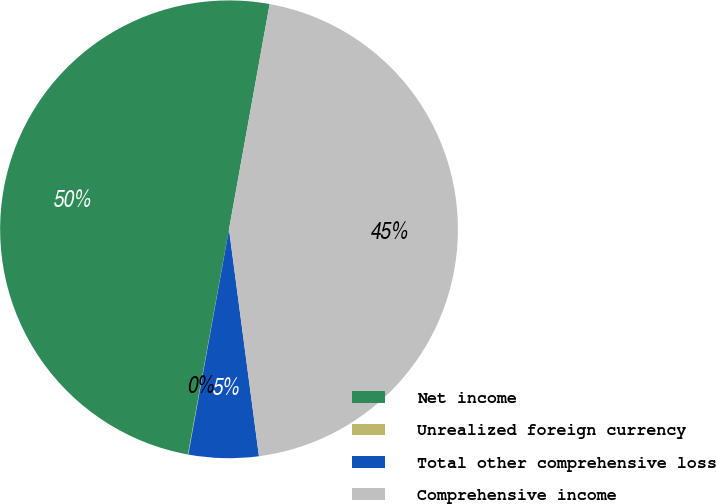Convert chart to OTSL. <chart><loc_0><loc_0><loc_500><loc_500><pie_chart><fcel>Net income<fcel>Unrealized foreign currency<fcel>Total other comprehensive loss<fcel>Comprehensive income<nl><fcel>49.97%<fcel>0.03%<fcel>4.93%<fcel>45.07%<nl></chart> 